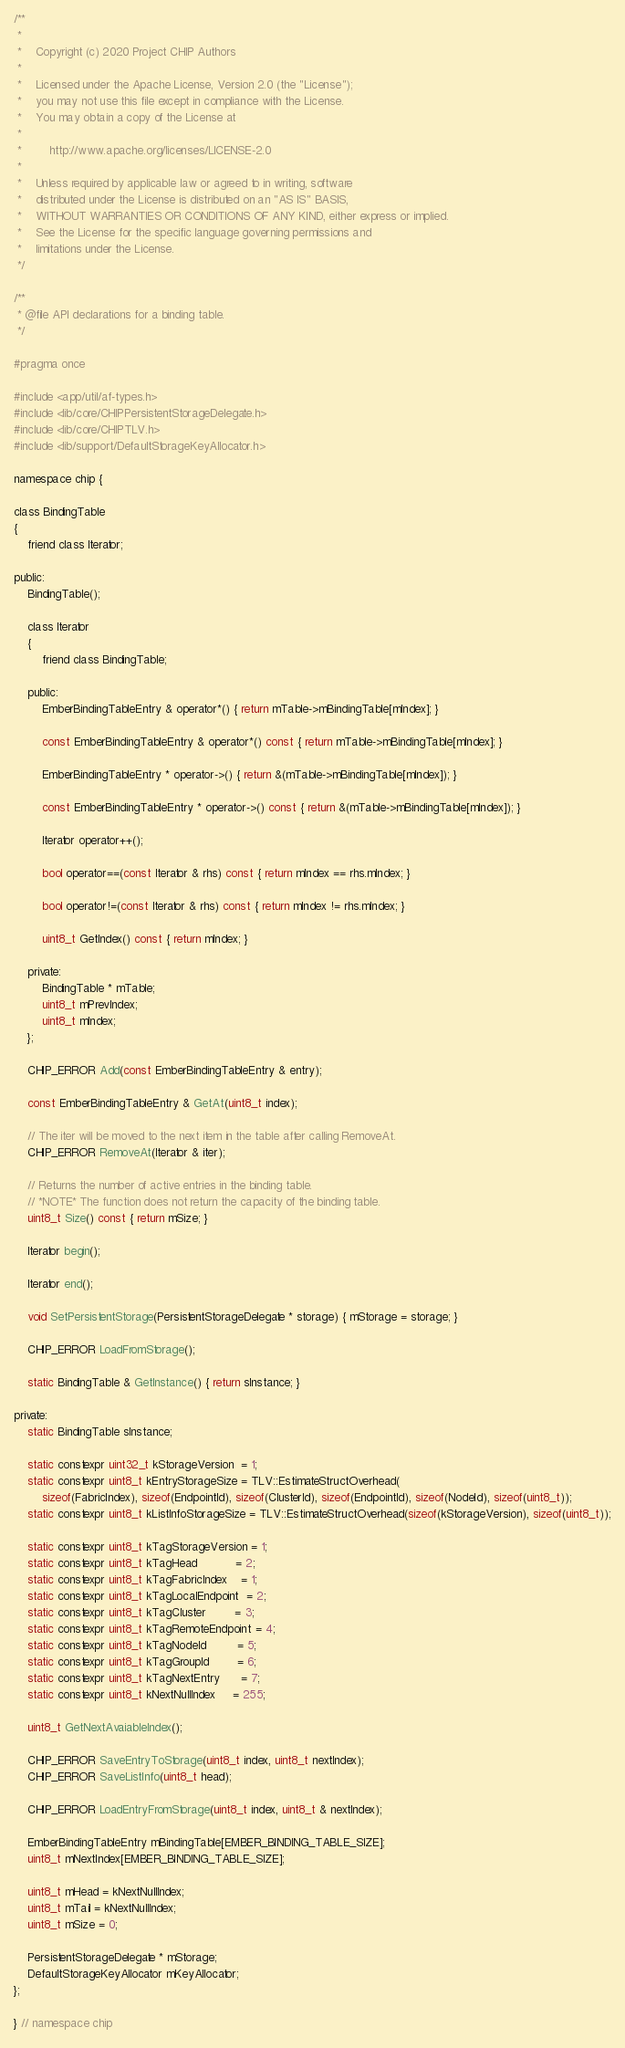<code> <loc_0><loc_0><loc_500><loc_500><_C_>/**
 *
 *    Copyright (c) 2020 Project CHIP Authors
 *
 *    Licensed under the Apache License, Version 2.0 (the "License");
 *    you may not use this file except in compliance with the License.
 *    You may obtain a copy of the License at
 *
 *        http://www.apache.org/licenses/LICENSE-2.0
 *
 *    Unless required by applicable law or agreed to in writing, software
 *    distributed under the License is distributed on an "AS IS" BASIS,
 *    WITHOUT WARRANTIES OR CONDITIONS OF ANY KIND, either express or implied.
 *    See the License for the specific language governing permissions and
 *    limitations under the License.
 */

/**
 * @file API declarations for a binding table.
 */

#pragma once

#include <app/util/af-types.h>
#include <lib/core/CHIPPersistentStorageDelegate.h>
#include <lib/core/CHIPTLV.h>
#include <lib/support/DefaultStorageKeyAllocator.h>

namespace chip {

class BindingTable
{
    friend class Iterator;

public:
    BindingTable();

    class Iterator
    {
        friend class BindingTable;

    public:
        EmberBindingTableEntry & operator*() { return mTable->mBindingTable[mIndex]; }

        const EmberBindingTableEntry & operator*() const { return mTable->mBindingTable[mIndex]; }

        EmberBindingTableEntry * operator->() { return &(mTable->mBindingTable[mIndex]); }

        const EmberBindingTableEntry * operator->() const { return &(mTable->mBindingTable[mIndex]); }

        Iterator operator++();

        bool operator==(const Iterator & rhs) const { return mIndex == rhs.mIndex; }

        bool operator!=(const Iterator & rhs) const { return mIndex != rhs.mIndex; }

        uint8_t GetIndex() const { return mIndex; }

    private:
        BindingTable * mTable;
        uint8_t mPrevIndex;
        uint8_t mIndex;
    };

    CHIP_ERROR Add(const EmberBindingTableEntry & entry);

    const EmberBindingTableEntry & GetAt(uint8_t index);

    // The iter will be moved to the next item in the table after calling RemoveAt.
    CHIP_ERROR RemoveAt(Iterator & iter);

    // Returns the number of active entries in the binding table.
    // *NOTE* The function does not return the capacity of the binding table.
    uint8_t Size() const { return mSize; }

    Iterator begin();

    Iterator end();

    void SetPersistentStorage(PersistentStorageDelegate * storage) { mStorage = storage; }

    CHIP_ERROR LoadFromStorage();

    static BindingTable & GetInstance() { return sInstance; }

private:
    static BindingTable sInstance;

    static constexpr uint32_t kStorageVersion  = 1;
    static constexpr uint8_t kEntryStorageSize = TLV::EstimateStructOverhead(
        sizeof(FabricIndex), sizeof(EndpointId), sizeof(ClusterId), sizeof(EndpointId), sizeof(NodeId), sizeof(uint8_t));
    static constexpr uint8_t kListInfoStorageSize = TLV::EstimateStructOverhead(sizeof(kStorageVersion), sizeof(uint8_t));

    static constexpr uint8_t kTagStorageVersion = 1;
    static constexpr uint8_t kTagHead           = 2;
    static constexpr uint8_t kTagFabricIndex    = 1;
    static constexpr uint8_t kTagLocalEndpoint  = 2;
    static constexpr uint8_t kTagCluster        = 3;
    static constexpr uint8_t kTagRemoteEndpoint = 4;
    static constexpr uint8_t kTagNodeId         = 5;
    static constexpr uint8_t kTagGroupId        = 6;
    static constexpr uint8_t kTagNextEntry      = 7;
    static constexpr uint8_t kNextNullIndex     = 255;

    uint8_t GetNextAvaiableIndex();

    CHIP_ERROR SaveEntryToStorage(uint8_t index, uint8_t nextIndex);
    CHIP_ERROR SaveListInfo(uint8_t head);

    CHIP_ERROR LoadEntryFromStorage(uint8_t index, uint8_t & nextIndex);

    EmberBindingTableEntry mBindingTable[EMBER_BINDING_TABLE_SIZE];
    uint8_t mNextIndex[EMBER_BINDING_TABLE_SIZE];

    uint8_t mHead = kNextNullIndex;
    uint8_t mTail = kNextNullIndex;
    uint8_t mSize = 0;

    PersistentStorageDelegate * mStorage;
    DefaultStorageKeyAllocator mKeyAllocator;
};

} // namespace chip
</code> 